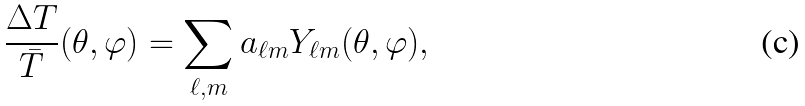<formula> <loc_0><loc_0><loc_500><loc_500>\frac { \Delta T } { \bar { T } } ( \theta , \varphi ) = \sum _ { \ell , m } a _ { \ell m } Y _ { \ell m } ( \theta , \varphi ) ,</formula> 